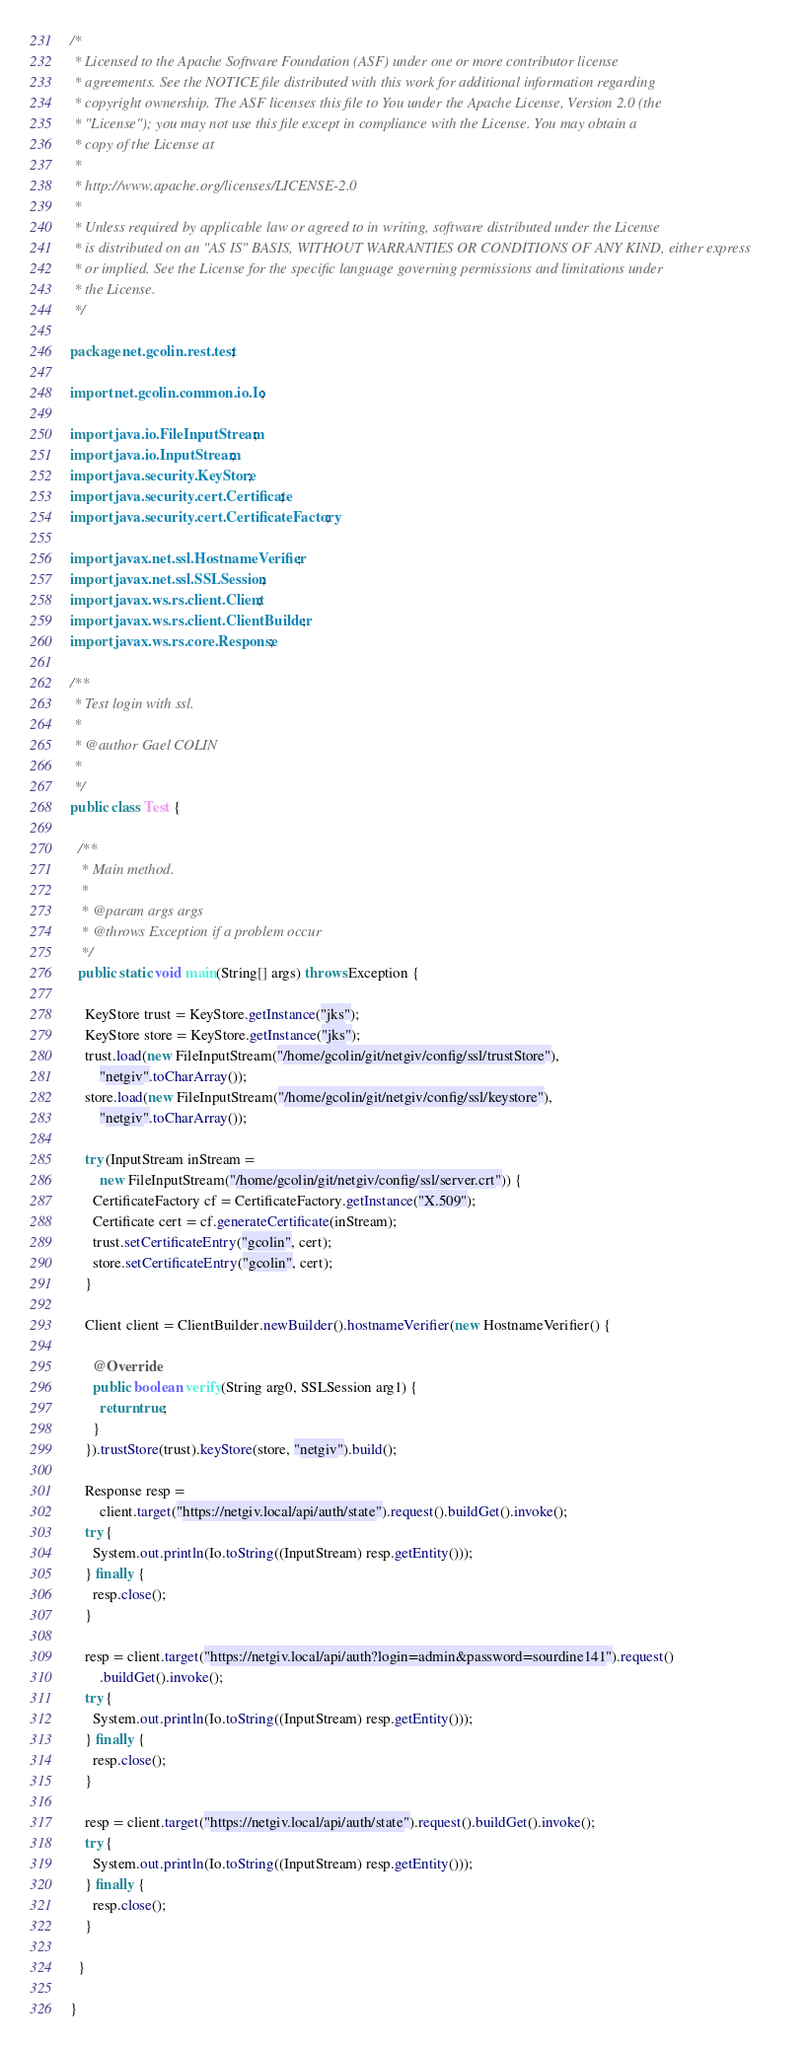<code> <loc_0><loc_0><loc_500><loc_500><_Java_>/*
 * Licensed to the Apache Software Foundation (ASF) under one or more contributor license
 * agreements. See the NOTICE file distributed with this work for additional information regarding
 * copyright ownership. The ASF licenses this file to You under the Apache License, Version 2.0 (the
 * "License"); you may not use this file except in compliance with the License. You may obtain a
 * copy of the License at
 *
 * http://www.apache.org/licenses/LICENSE-2.0
 *
 * Unless required by applicable law or agreed to in writing, software distributed under the License
 * is distributed on an "AS IS" BASIS, WITHOUT WARRANTIES OR CONDITIONS OF ANY KIND, either express
 * or implied. See the License for the specific language governing permissions and limitations under
 * the License.
 */

package net.gcolin.rest.test;

import net.gcolin.common.io.Io;

import java.io.FileInputStream;
import java.io.InputStream;
import java.security.KeyStore;
import java.security.cert.Certificate;
import java.security.cert.CertificateFactory;

import javax.net.ssl.HostnameVerifier;
import javax.net.ssl.SSLSession;
import javax.ws.rs.client.Client;
import javax.ws.rs.client.ClientBuilder;
import javax.ws.rs.core.Response;

/**
 * Test login with ssl.
 * 
 * @author Gael COLIN
 *
 */
public class Test {

  /**
   * Main method.
   * 
   * @param args args
   * @throws Exception if a problem occur
   */
  public static void main(String[] args) throws Exception {

    KeyStore trust = KeyStore.getInstance("jks");
    KeyStore store = KeyStore.getInstance("jks");
    trust.load(new FileInputStream("/home/gcolin/git/netgiv/config/ssl/trustStore"),
        "netgiv".toCharArray());
    store.load(new FileInputStream("/home/gcolin/git/netgiv/config/ssl/keystore"),
        "netgiv".toCharArray());

    try (InputStream inStream =
        new FileInputStream("/home/gcolin/git/netgiv/config/ssl/server.crt")) {
      CertificateFactory cf = CertificateFactory.getInstance("X.509");
      Certificate cert = cf.generateCertificate(inStream);
      trust.setCertificateEntry("gcolin", cert);
      store.setCertificateEntry("gcolin", cert);
    }

    Client client = ClientBuilder.newBuilder().hostnameVerifier(new HostnameVerifier() {

      @Override
      public boolean verify(String arg0, SSLSession arg1) {
        return true;
      }
    }).trustStore(trust).keyStore(store, "netgiv").build();

    Response resp =
        client.target("https://netgiv.local/api/auth/state").request().buildGet().invoke();
    try {
      System.out.println(Io.toString((InputStream) resp.getEntity()));
    } finally {
      resp.close();
    }

    resp = client.target("https://netgiv.local/api/auth?login=admin&password=sourdine141").request()
        .buildGet().invoke();
    try {
      System.out.println(Io.toString((InputStream) resp.getEntity()));
    } finally {
      resp.close();
    }

    resp = client.target("https://netgiv.local/api/auth/state").request().buildGet().invoke();
    try {
      System.out.println(Io.toString((InputStream) resp.getEntity()));
    } finally {
      resp.close();
    }

  }

}
</code> 